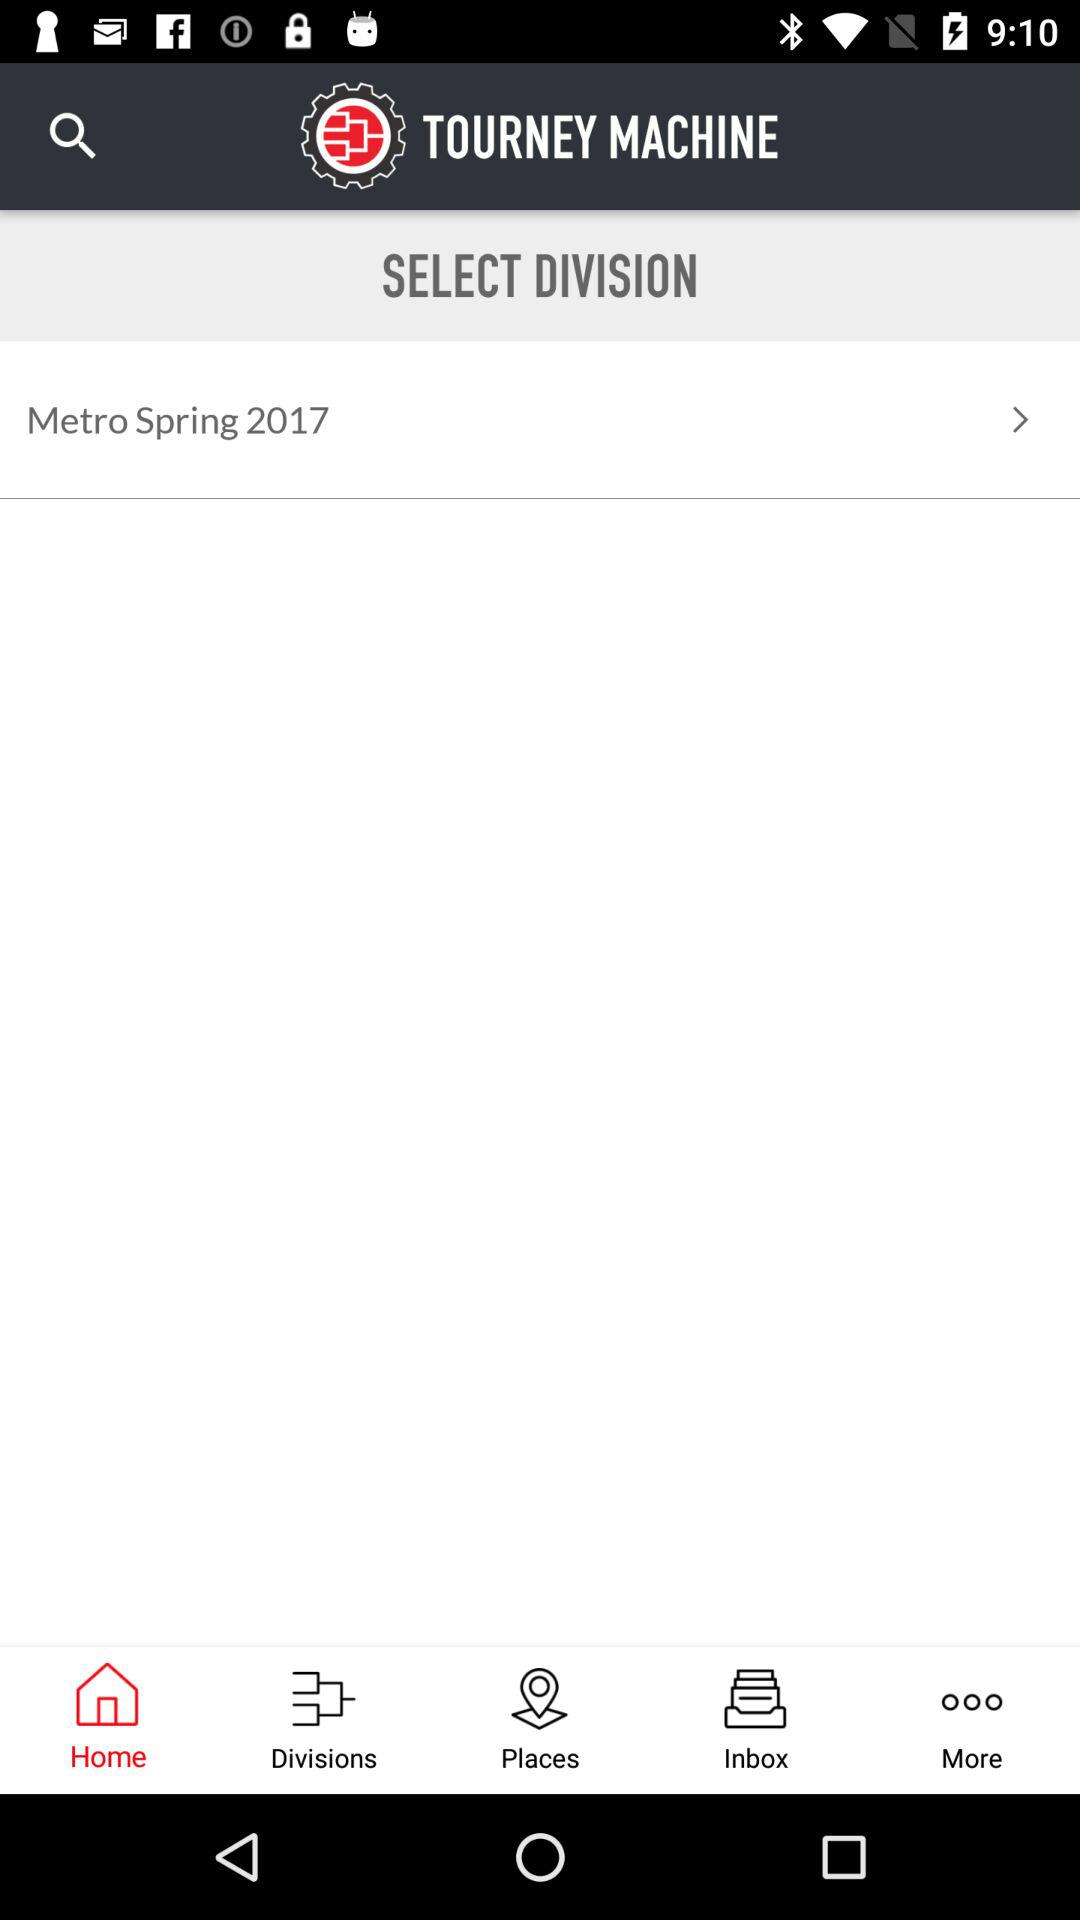What is the selected tab? The selected tab is "Home". 